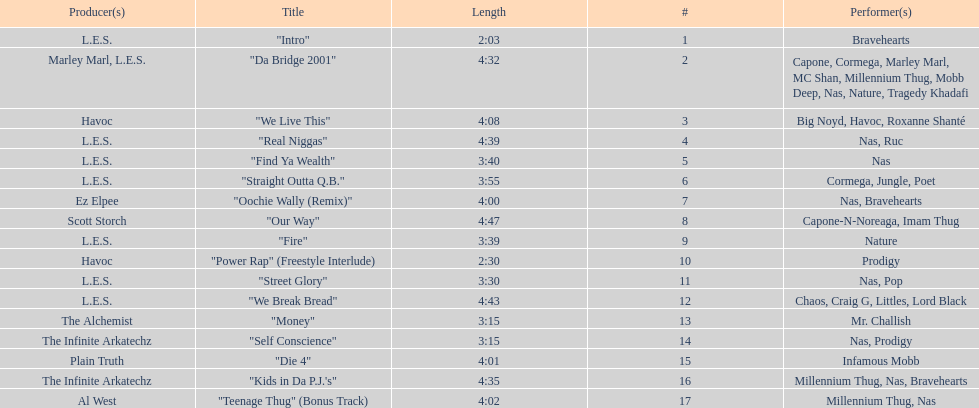What is the duration of the lengthiest track on the record? 4:47. 